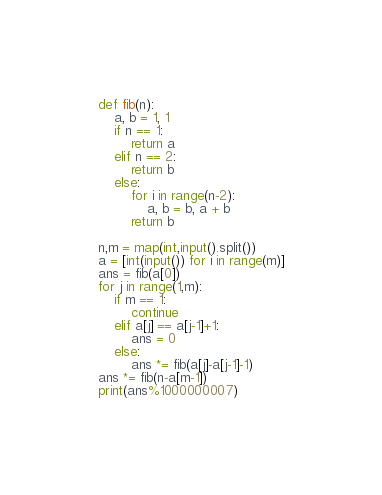<code> <loc_0><loc_0><loc_500><loc_500><_Python_>def fib(n):
    a, b = 1, 1
    if n == 1:
        return a
    elif n == 2:
        return b
    else:
        for i in range(n-2):
            a, b = b, a + b
        return b

n,m = map(int,input().split())
a = [int(input()) for i in range(m)]
ans = fib(a[0])
for j in range(1,m):
    if m == 1:
        continue
    elif a[j] == a[j-1]+1:
        ans = 0
    else:
        ans *= fib(a[j]-a[j-1]-1)
ans *= fib(n-a[m-1])
print(ans%1000000007)
</code> 